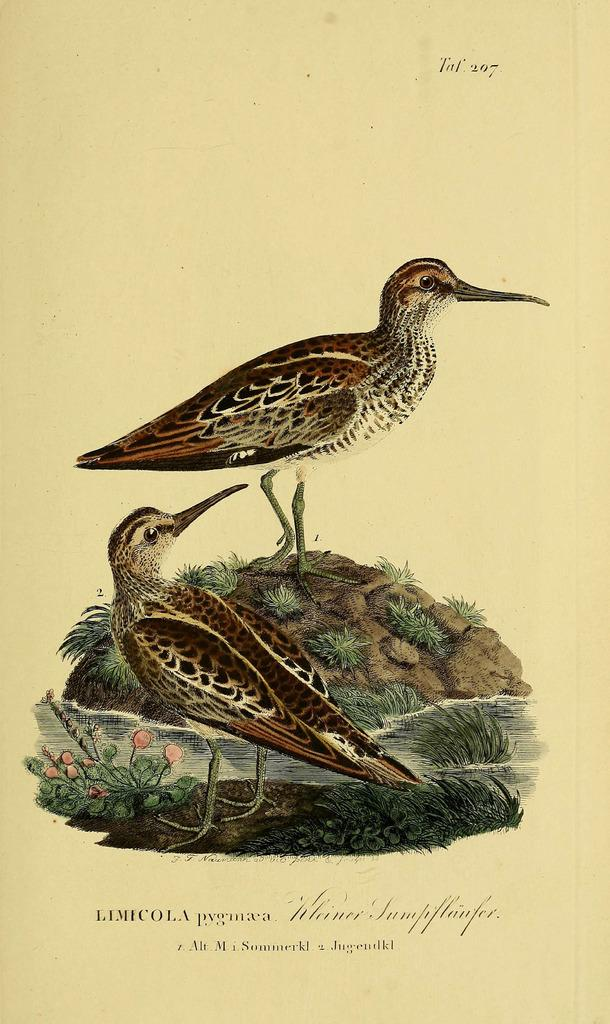What is the main subject of the drawing in the image? The drawing depicts two birds. Are there any other elements in the drawing besides the birds? Yes, the drawing also includes flowers. What is the medium of the drawing? The drawing is on a paper, as mentioned in the facts. What type of oatmeal is being served in the carriage in the image? There is no carriage or oatmeal present in the image; it features a drawing on a paper. How many cents are visible on the drawing in the image? There are no cents depicted in the drawing; it features two birds and flowers. 